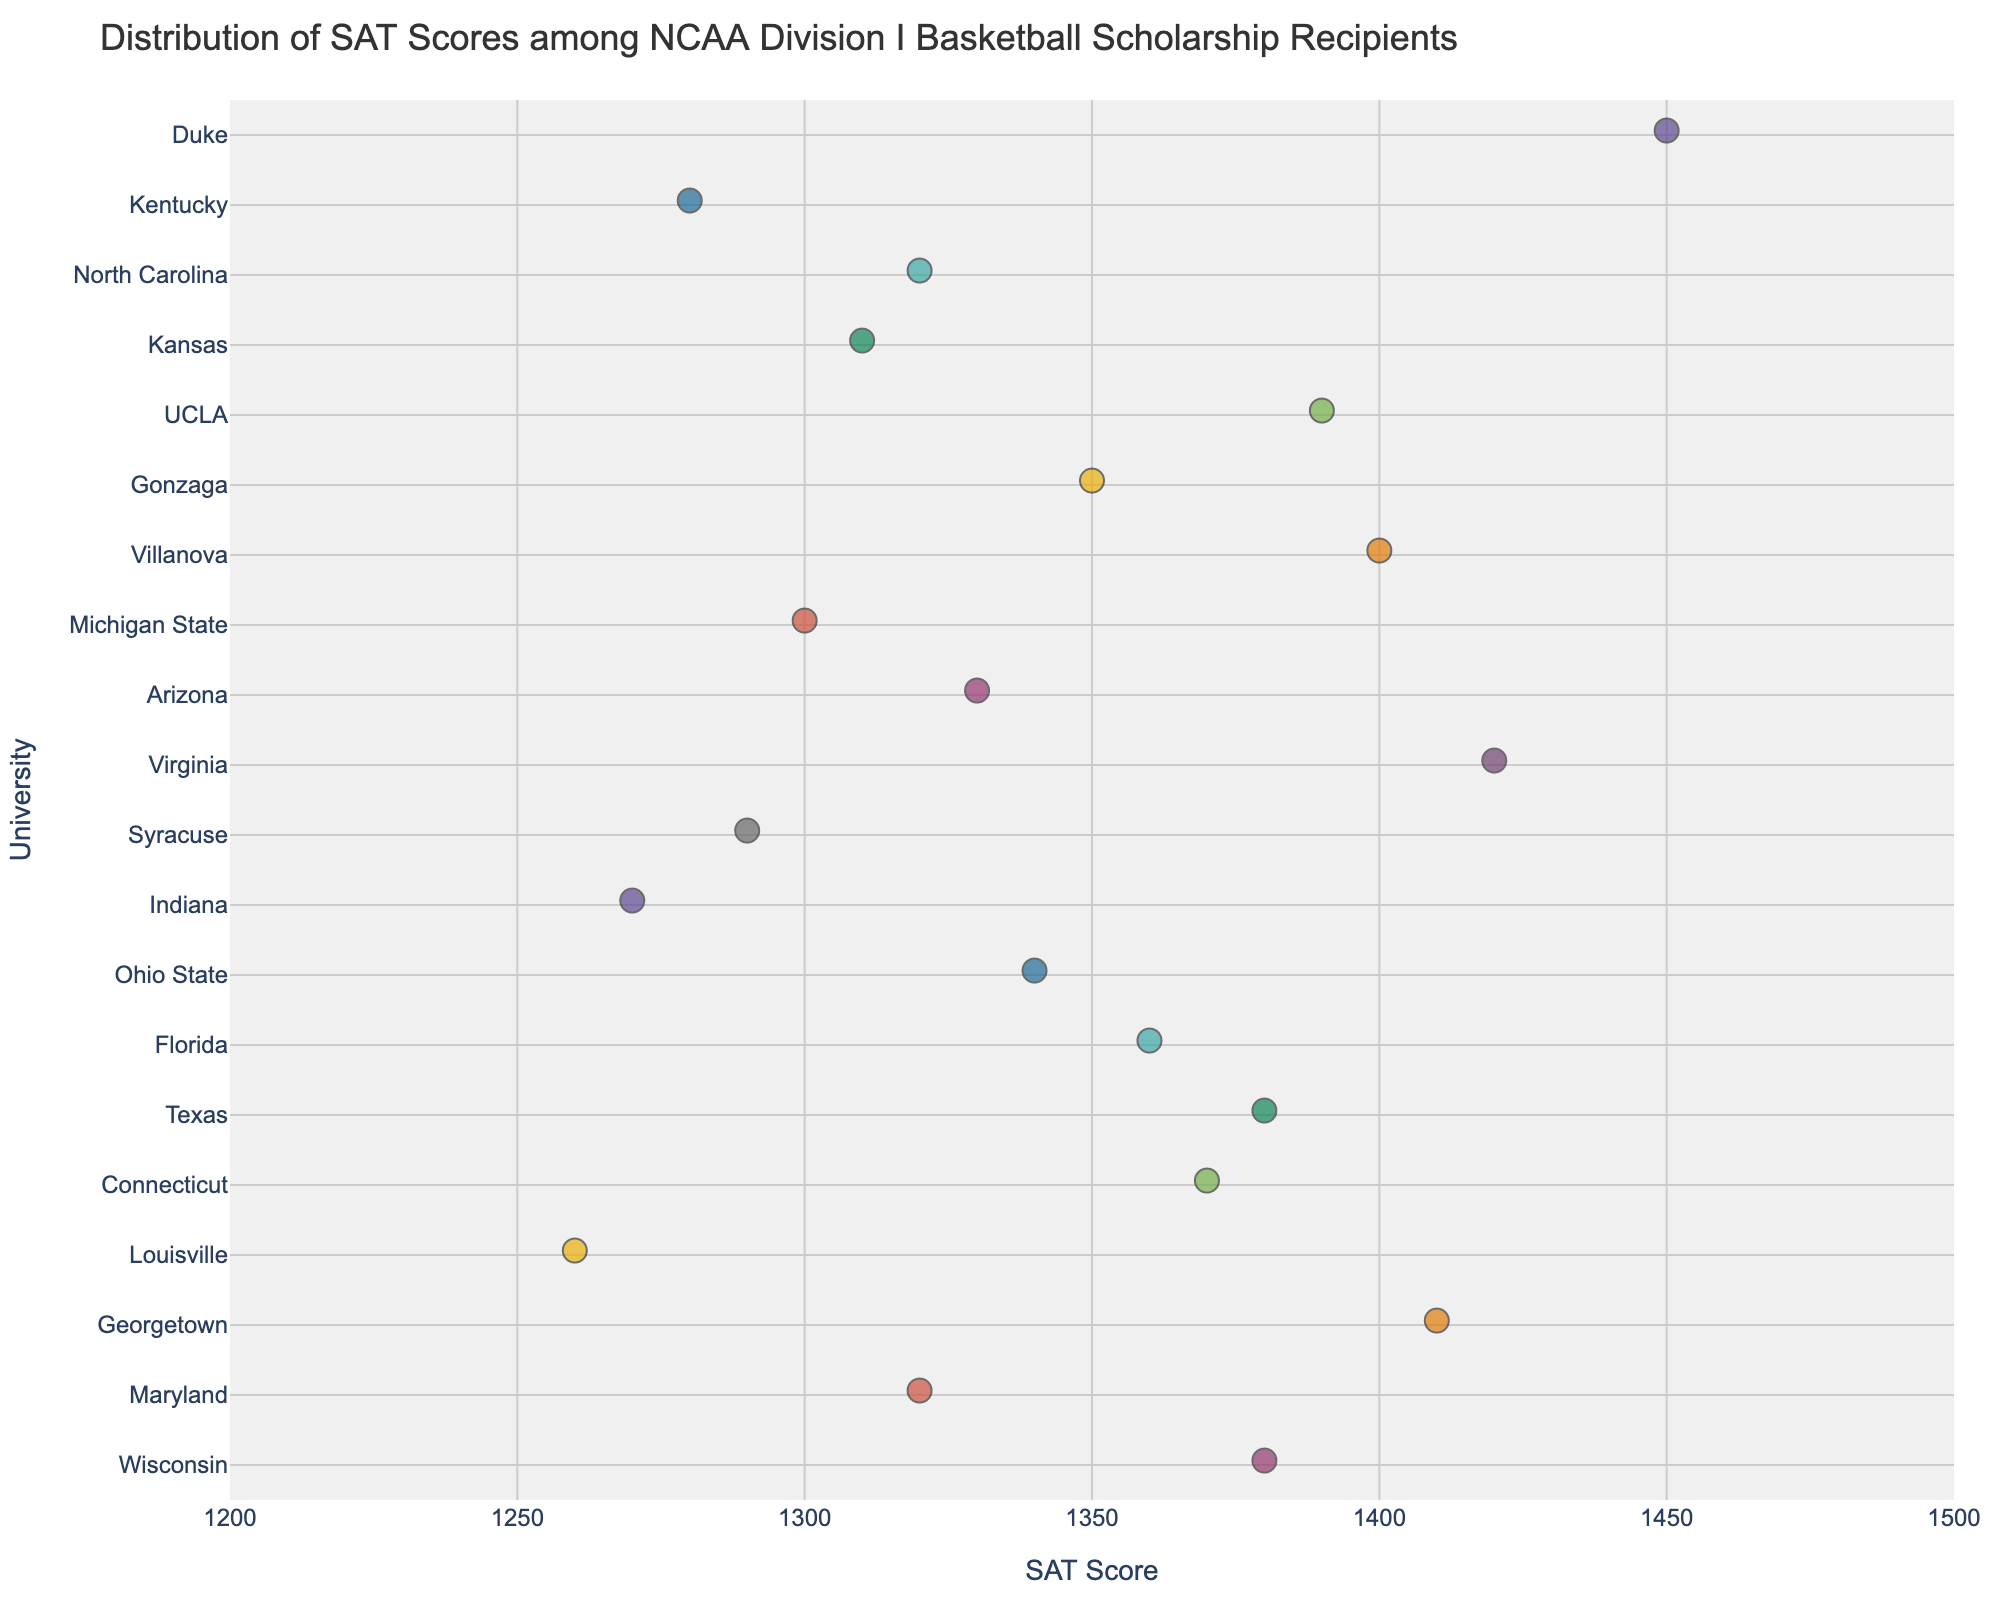what is the range of the SAT scores on the x-axis? The x-axis range extends from 1200 to 1500 as marked on the axis labels.
Answer: 1200 to 1500 Which university has the highest SAT score among the recipients? By looking at the distribution along the x-axis, Duke University has the highest SAT score with a score of 1450.
Answer: Duke What is the SAT score for Kentucky's basketball scholarship recipients? Locate Kentucky along the y-axis, and trace it horizontally to its data point at 1280.
Answer: 1280 Which university has the lowest SAT score among the recipients? By finding the left-most data point, Louisville has the lowest SAT score with a score of 1260.
Answer: Louisville What is the average SAT score of the universities shown in the plot? Sum the SAT scores of all universities and divide by the number of universities: (1450 + 1280 + 1320 + 1310 + 1390 + 1350 + 1400 + 1300 + 1330 + 1420 + 1290 + 1270 + 1340 + 1360 + 1380 + 1370 + 1260 + 1410 + 1320 + 1380) ÷ 20 = 1347.5
Answer: 1347.5 Which universities have SAT scores above 1400? Identify data points greater than 1400 along the x-axis: Duke (1450), Virginia (1420), Villanova (1400), Georgetown (1410).
Answer: Duke, Virginia, Villanova, Georgetown How many universities fall within the SAT score range of 1300 to 1350? Count the data points that lie between 1300 and 1350 along the x-axis: North Carolina (1320), Kansas (1310), Michigan State (1300), Arizona (1330), Ohio State (1340).
Answer: 5 What is the median SAT score among the universities? Arrange the SAT scores in ascending order and find the middle value: The ordered scores are [1260, 1270, 1280, 1290, 1300, 1310, 1320, 1320, 1330, 1340, 1350, 1360, 1370, 1380, 1380, 1390, 1400, 1410, 1420, 1450]. The median is the average of the 10th and 11th values, (1340+1350)/2 = 1345.
Answer: 1345 